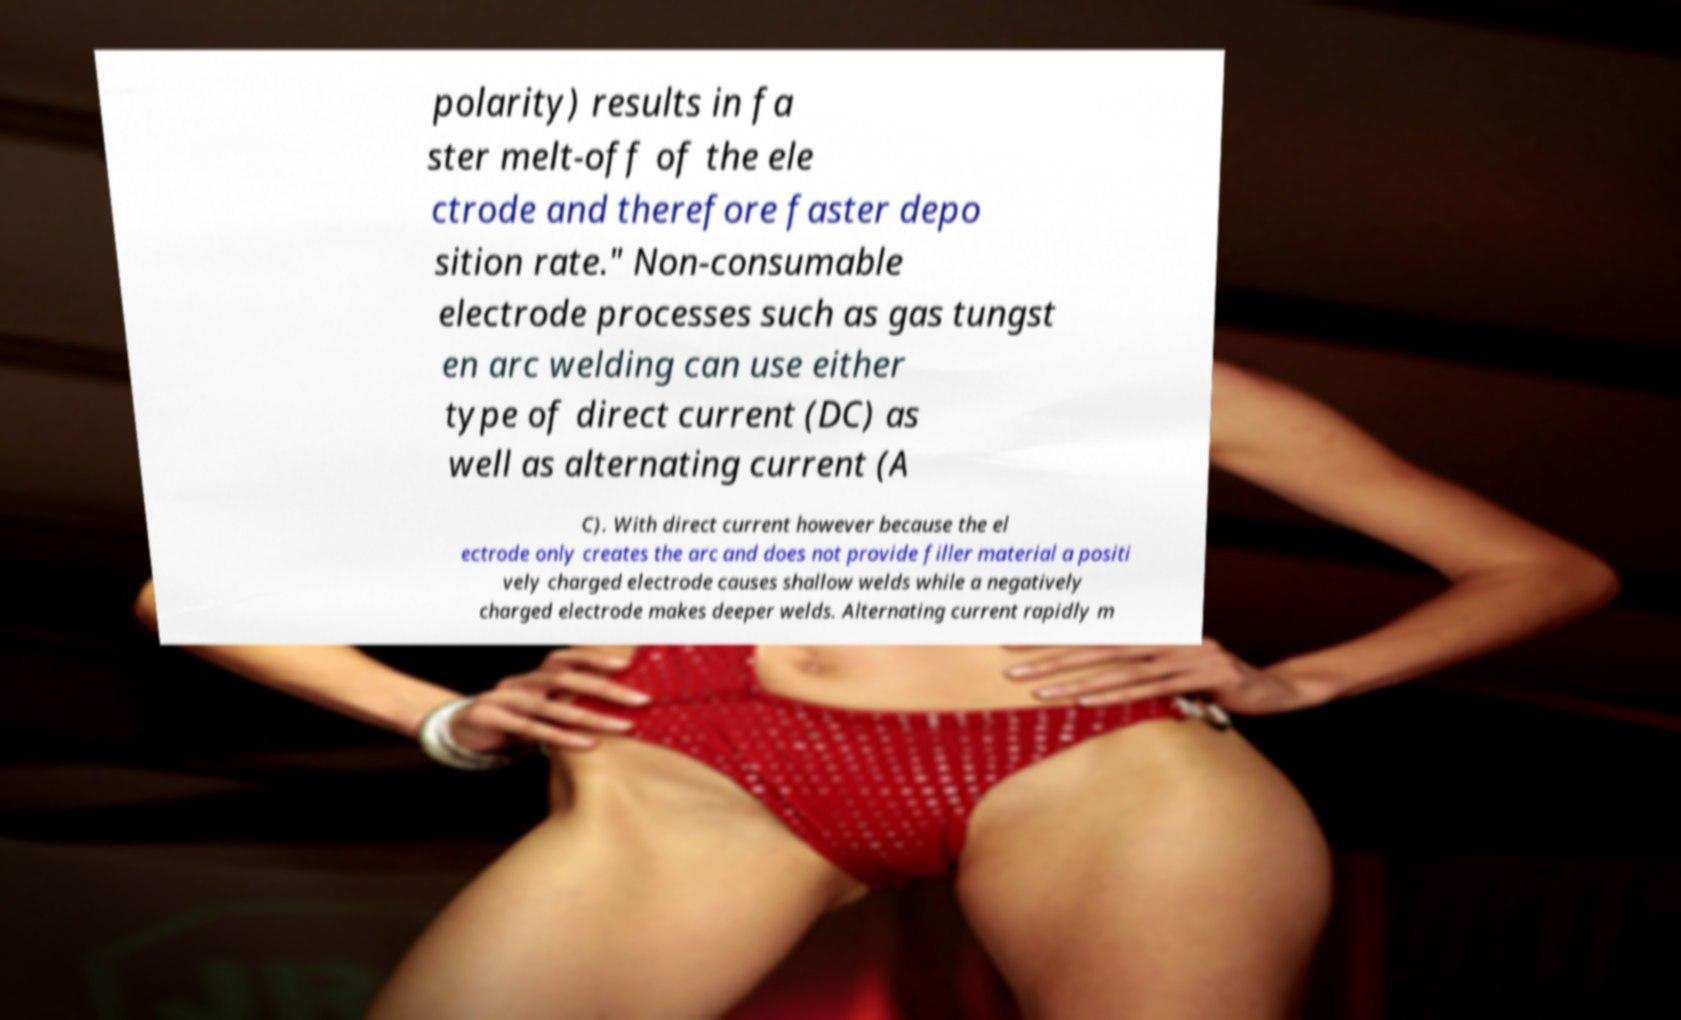I need the written content from this picture converted into text. Can you do that? polarity) results in fa ster melt-off of the ele ctrode and therefore faster depo sition rate." Non-consumable electrode processes such as gas tungst en arc welding can use either type of direct current (DC) as well as alternating current (A C). With direct current however because the el ectrode only creates the arc and does not provide filler material a positi vely charged electrode causes shallow welds while a negatively charged electrode makes deeper welds. Alternating current rapidly m 